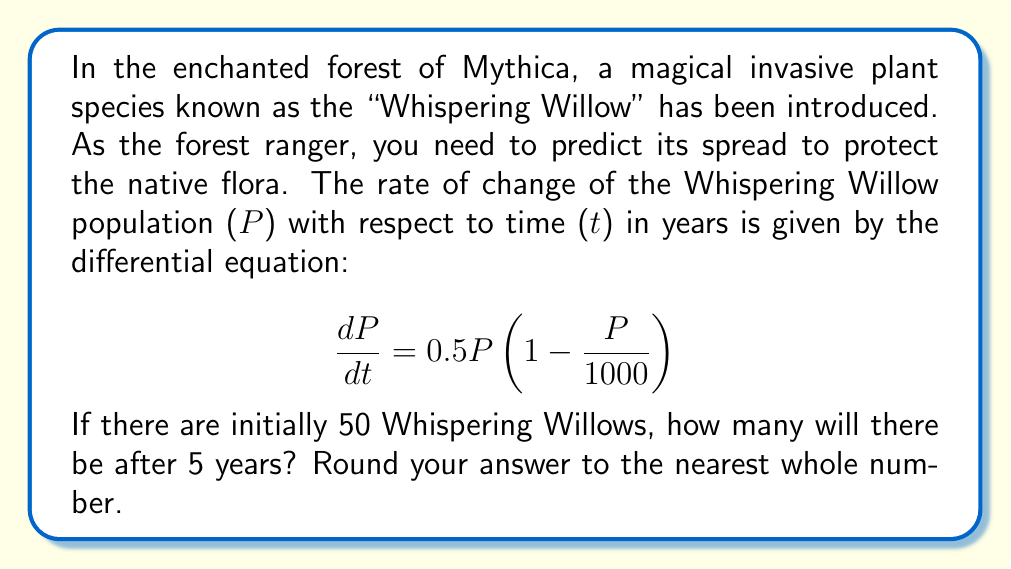Show me your answer to this math problem. To solve this problem, we need to use the logistic growth model, which is described by the given differential equation. Let's approach this step-by-step:

1) The given differential equation is:
   $$\frac{dP}{dt} = 0.5P(1 - \frac{P}{1000})$$

2) This is a separable differential equation. We can solve it as follows:
   $$\int \frac{dP}{P(1 - \frac{P}{1000})} = \int 0.5 dt$$

3) The left side can be solved using partial fractions:
   $$\int (\frac{1}{P} + \frac{1}{1000 - P}) dP = 0.5t + C$$

4) Solving this integral gives us:
   $$\ln|P| - \ln|1000 - P| = 0.5t + C$$

5) Simplifying and using the initial condition P(0) = 50:
   $$\ln(\frac{P}{1000 - P}) = 0.5t + \ln(\frac{50}{950})$$

6) Solving for P:
   $$P = \frac{1000}{1 + 19e^{-0.5t}}$$

7) Now, we can find P when t = 5:
   $$P(5) = \frac{1000}{1 + 19e^{-0.5(5)}} \approx 236.98$$

8) Rounding to the nearest whole number:
   P(5) ≈ 237
Answer: 237 